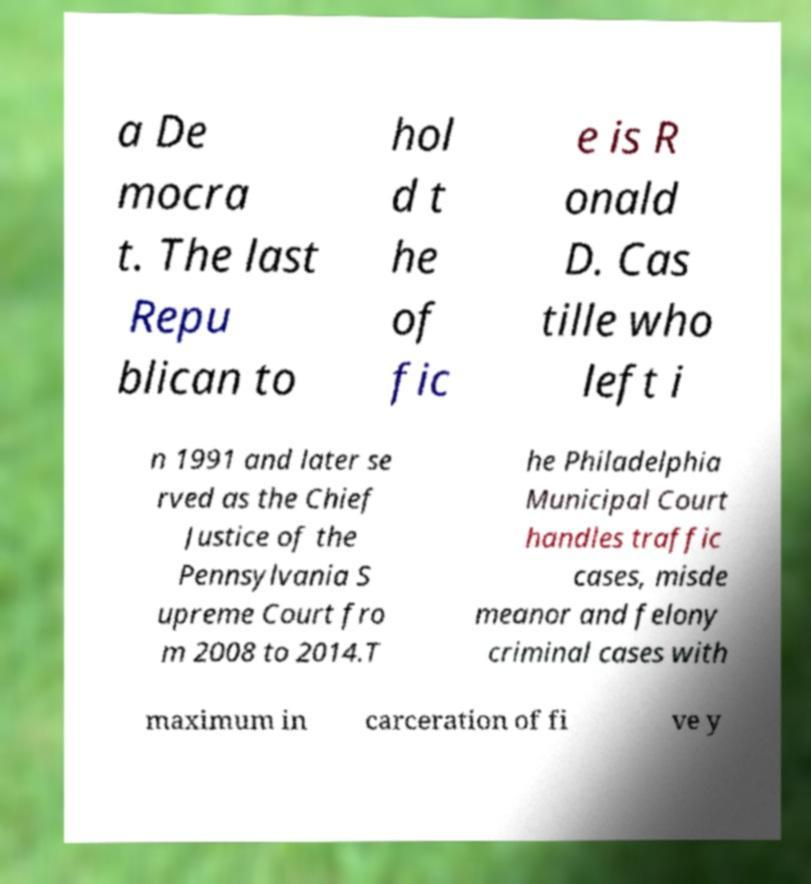I need the written content from this picture converted into text. Can you do that? a De mocra t. The last Repu blican to hol d t he of fic e is R onald D. Cas tille who left i n 1991 and later se rved as the Chief Justice of the Pennsylvania S upreme Court fro m 2008 to 2014.T he Philadelphia Municipal Court handles traffic cases, misde meanor and felony criminal cases with maximum in carceration of fi ve y 